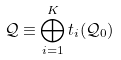Convert formula to latex. <formula><loc_0><loc_0><loc_500><loc_500>\mathcal { Q } \equiv \bigoplus _ { i = 1 } ^ { K } t _ { i } ( \mathcal { Q } _ { 0 } )</formula> 